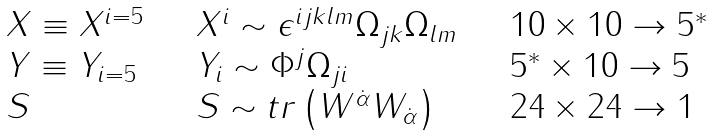Convert formula to latex. <formula><loc_0><loc_0><loc_500><loc_500>\begin{array} { l l l } { { X \equiv X ^ { i = 5 } \quad } } & { { X ^ { i } \sim \epsilon ^ { i j k l m } \Omega _ { j k } \Omega _ { l m } } } & { { \quad 1 0 \times 1 0 \rightarrow 5 ^ { * } } } \\ { { Y \equiv Y _ { i = 5 } \quad } } & { { Y _ { i } \sim \Phi ^ { j } \Omega _ { j i } } } & { { \quad 5 ^ { * } \times 1 0 \rightarrow 5 } } \\ { S } & { { S \sim t r \left ( W ^ { \dot { \alpha } } W _ { \dot { \alpha } } \right ) } } & { \quad 2 4 \times 2 4 \rightarrow 1 } \end{array}</formula> 